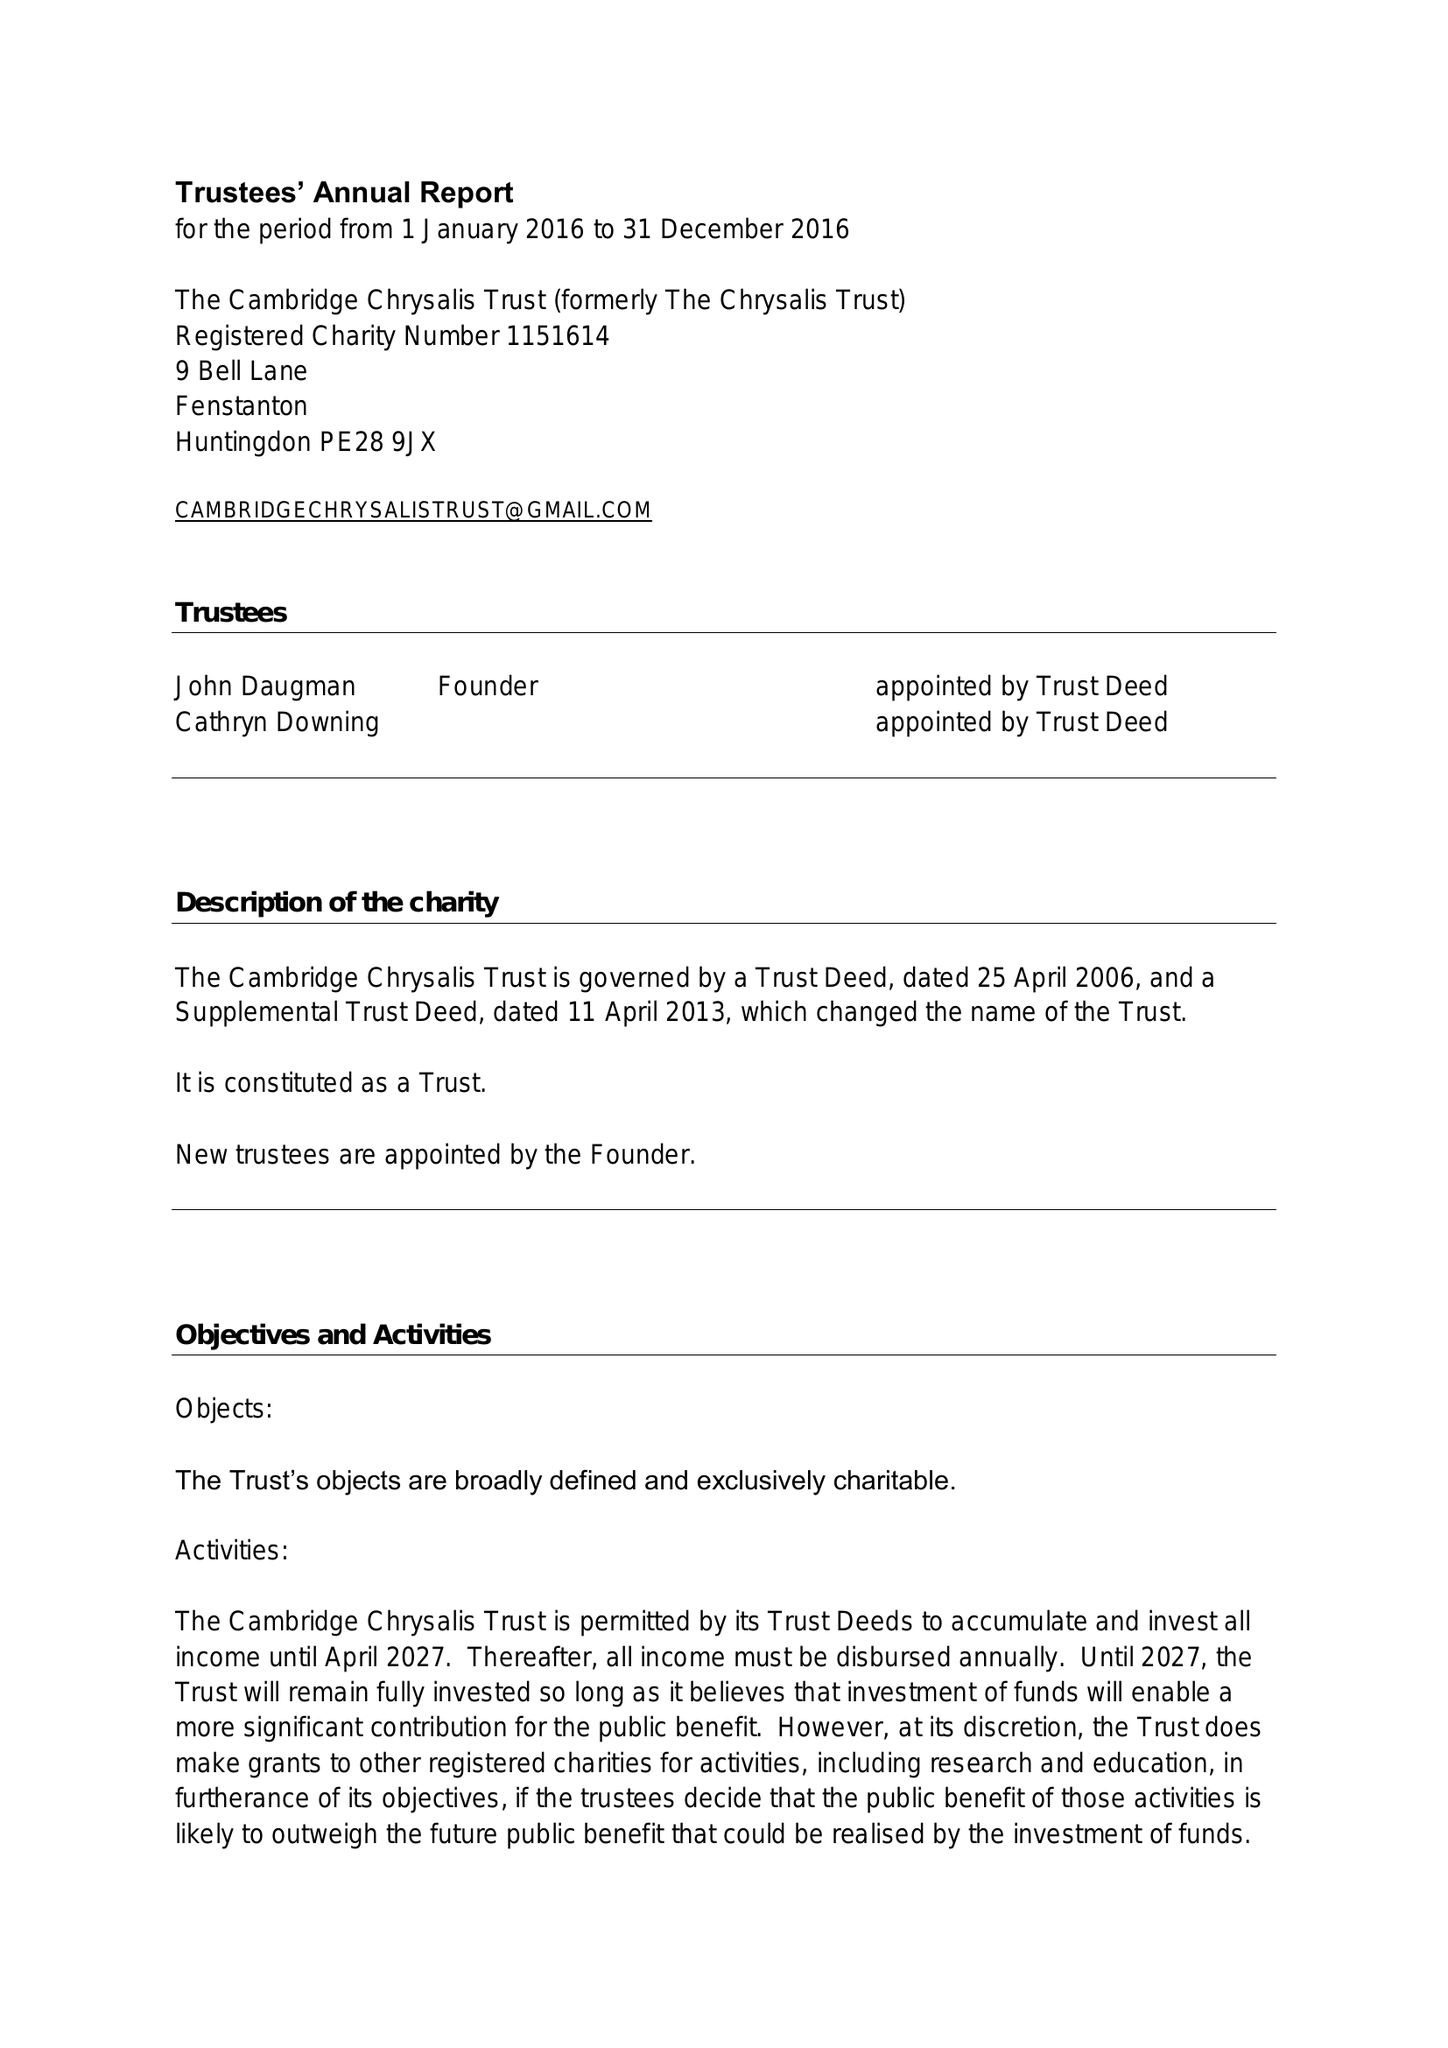What is the value for the charity_number?
Answer the question using a single word or phrase. 1151614 